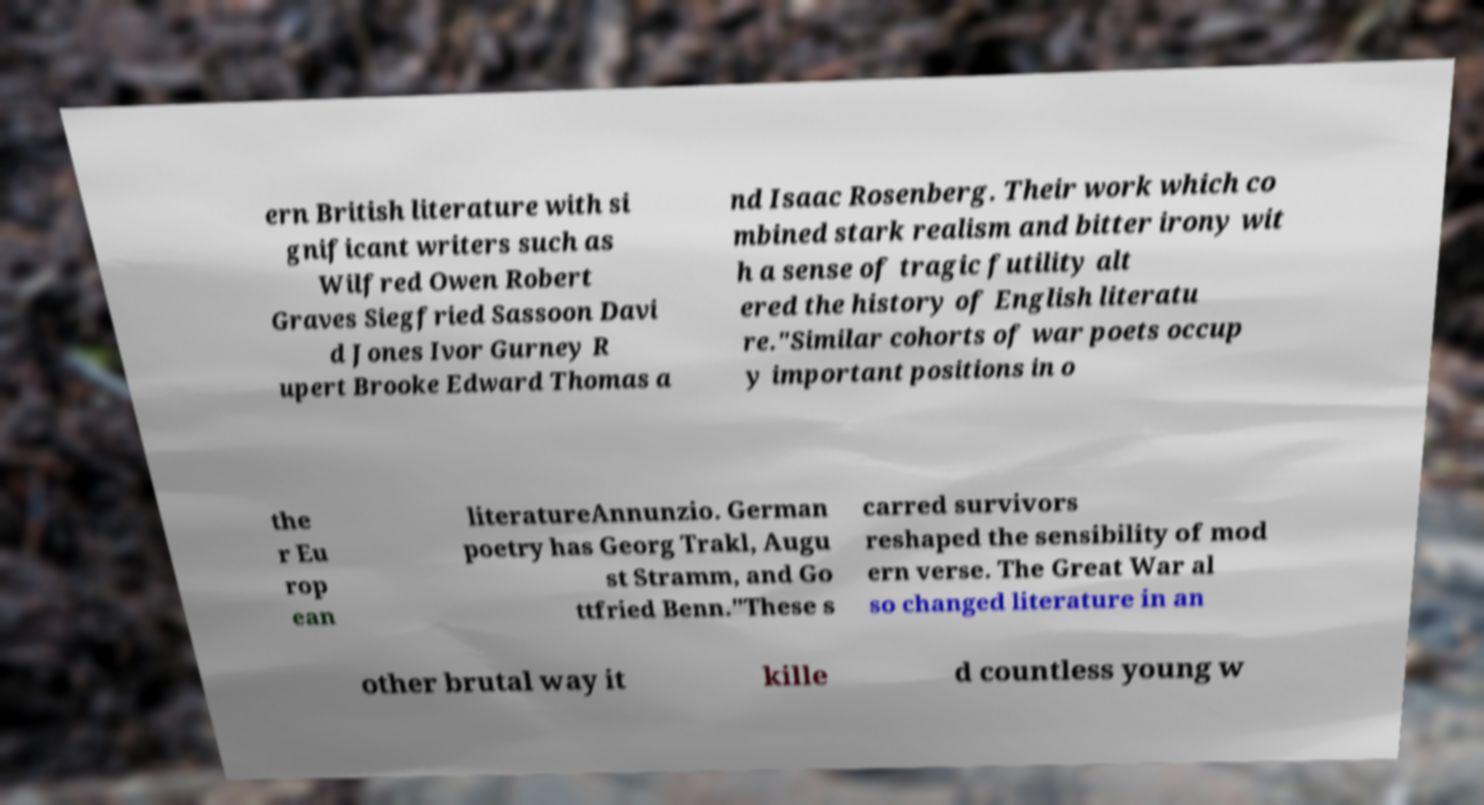Could you assist in decoding the text presented in this image and type it out clearly? ern British literature with si gnificant writers such as Wilfred Owen Robert Graves Siegfried Sassoon Davi d Jones Ivor Gurney R upert Brooke Edward Thomas a nd Isaac Rosenberg. Their work which co mbined stark realism and bitter irony wit h a sense of tragic futility alt ered the history of English literatu re."Similar cohorts of war poets occup y important positions in o the r Eu rop ean literatureAnnunzio. German poetry has Georg Trakl, Augu st Stramm, and Go ttfried Benn."These s carred survivors reshaped the sensibility of mod ern verse. The Great War al so changed literature in an other brutal way it kille d countless young w 